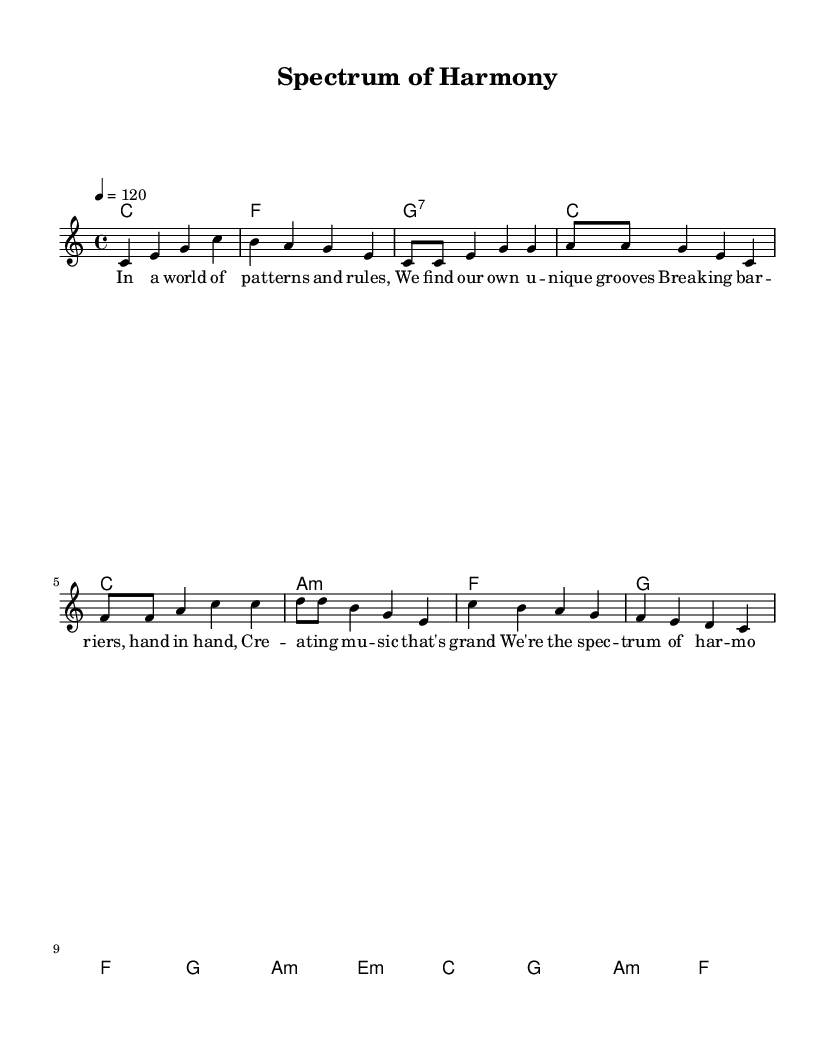What is the key signature of this music? The key signature corresponds to the indicated key, which is C major. In the music, there are no sharps or flats shown before the notes, confirming that it is in C major.
Answer: C major What is the time signature of this music? The time signature is indicated at the beginning of the score. It shows 4 beats per measure, which is represented as 4/4, a common time signature in many K-Pop songs.
Answer: 4/4 What is the tempo marking for this piece? The tempo is specified in beats per minute, indicated by the marking "4 = 120." This means that there are 120 beats in one minute, reflecting a moderately lively pace typical for K-Pop.
Answer: 120 How many measures are in the chorus section? To determine the number of measures in the chorus, we count the measures in the "Chorus" segment of the score, which has 4 measures: c, g, a minor, and f chords.
Answer: 4 What is the lyrical theme conveyed in the verse? The lyrics in the verse focus on themes of individuality and unity within diversity, emphasizing breaking barriers and creating music together. This collaborative spirit is a common theme in K-Pop, particularly in projects embracing neurodiversity.
Answer: Individuality and unity Is the composition likely to include a bridge section? Observing the structure of K-Pop, this piece does not explicitly have a bridge indicated within the provided music, as it includes intro, verse, pre-chorus, and chorus sections. Typically, K-Pop songs use bridges, but here it is absent based on the measures shown.
Answer: No What type of harmony is primarily used in this piece? The harmony displays a combination of major and minor chords throughout the sections. This is typical in K-Pop to create a colorful and engaging sound. The use of a minor chord, particularly in the pre-chorus, adds emotional depth.
Answer: Major and minor 